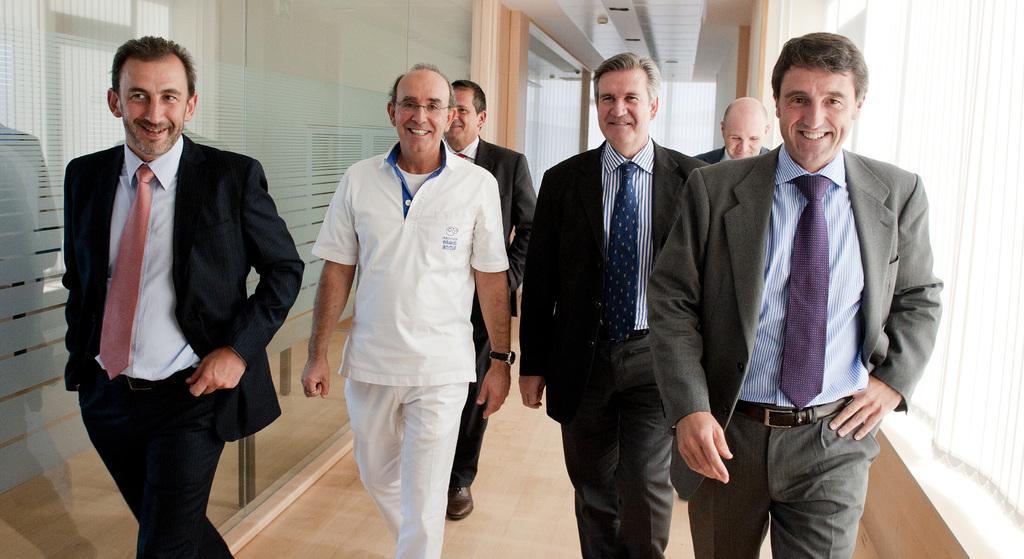Could you give a brief overview of what you see in this image? This image is taken indoors. At the bottom of the image there is a floor. In the background there is a wall with glass doors and curtains. At the top of the image there is a ceiling. In the middle of the image six men are walking on the floor. They have worn suits, ties and shirts. 